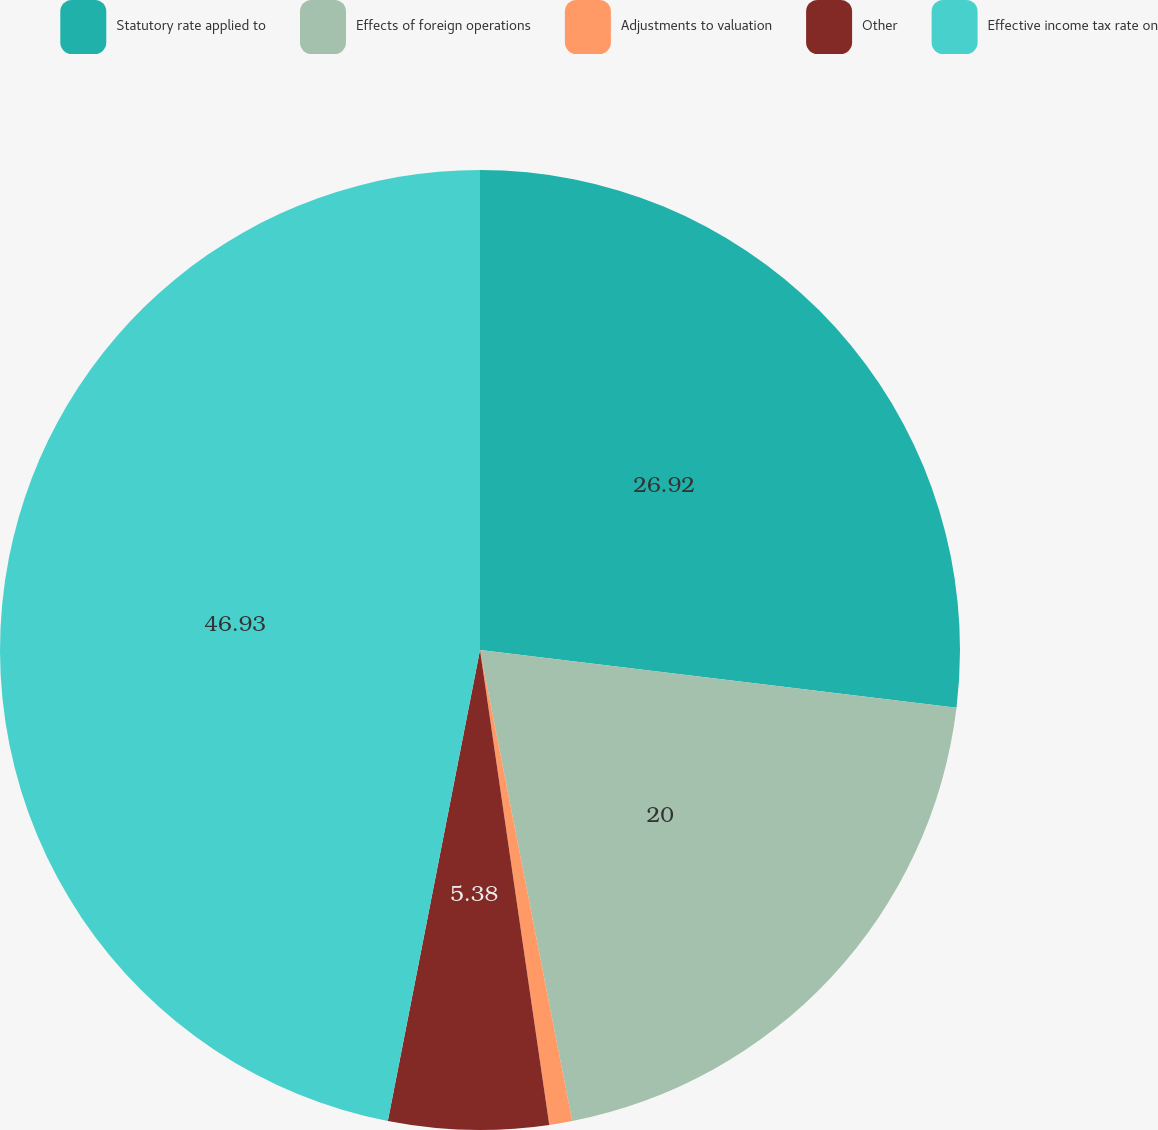Convert chart to OTSL. <chart><loc_0><loc_0><loc_500><loc_500><pie_chart><fcel>Statutory rate applied to<fcel>Effects of foreign operations<fcel>Adjustments to valuation<fcel>Other<fcel>Effective income tax rate on<nl><fcel>26.92%<fcel>20.0%<fcel>0.77%<fcel>5.38%<fcel>46.92%<nl></chart> 